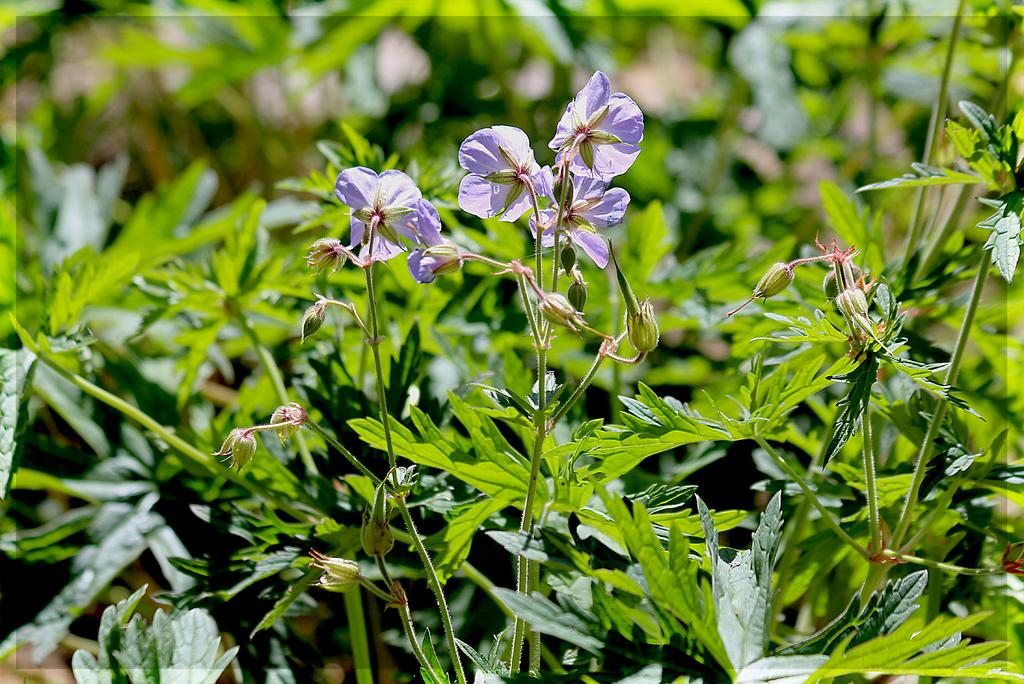What type of flora can be seen in the image? There are flowers in the image. Can you describe the flowers in more detail? The flowers have buds on the stems. What else can be seen in the background of the image? There are plants visible behind the flowers. What is the route taken by the bun in the image? There is no bun present in the image, so it is not possible to determine a route. 